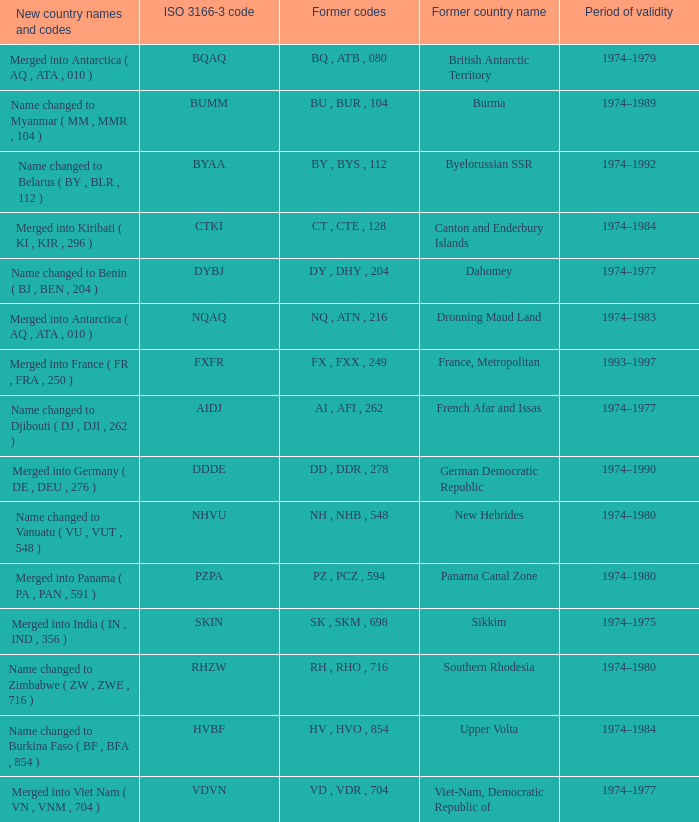Name the total number for period of validity for upper volta 1.0. 